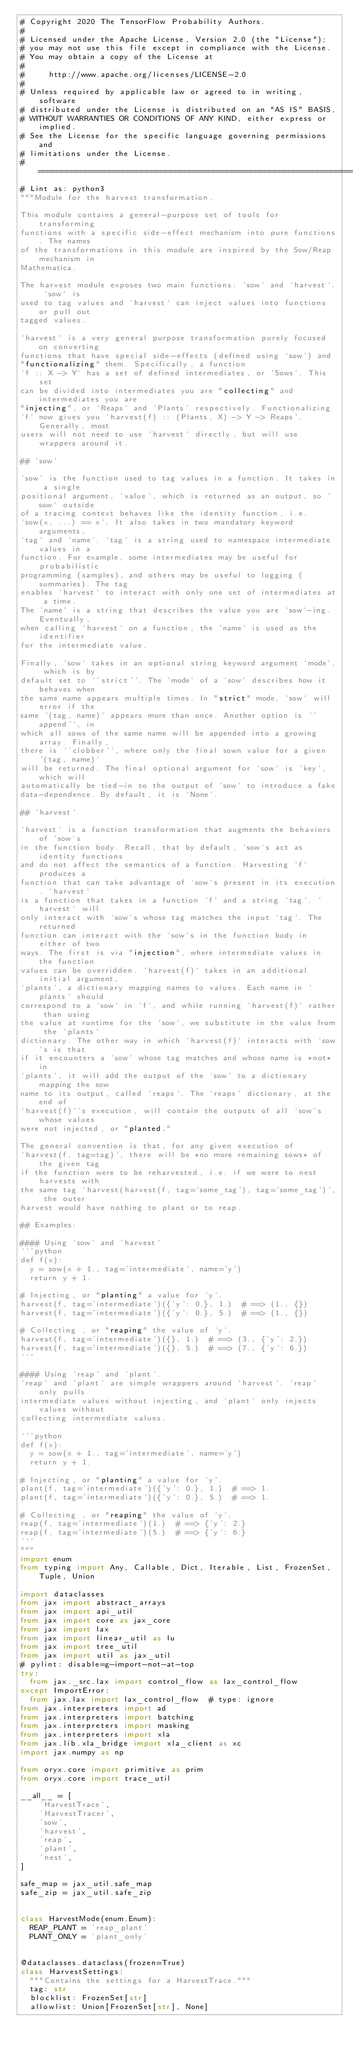<code> <loc_0><loc_0><loc_500><loc_500><_Python_># Copyright 2020 The TensorFlow Probability Authors.
#
# Licensed under the Apache License, Version 2.0 (the "License");
# you may not use this file except in compliance with the License.
# You may obtain a copy of the License at
#
#     http://www.apache.org/licenses/LICENSE-2.0
#
# Unless required by applicable law or agreed to in writing, software
# distributed under the License is distributed on an "AS IS" BASIS,
# WITHOUT WARRANTIES OR CONDITIONS OF ANY KIND, either express or implied.
# See the License for the specific language governing permissions and
# limitations under the License.
# ============================================================================
# Lint as: python3
"""Module for the harvest transformation.

This module contains a general-purpose set of tools for transforming
functions with a specific side-effect mechanism into pure functions. The names
of the transformations in this module are inspired by the Sow/Reap mechanism in
Mathematica.

The harvest module exposes two main functions: `sow` and `harvest`. `sow` is
used to tag values and `harvest` can inject values into functions or pull out
tagged values.

`harvest` is a very general purpose transformation purely focused on converting
functions that have special side-effects (defined using `sow`) and
"functionalizing" them. Specifically, a function
`f :: X -> Y` has a set of defined intermediates, or `Sows`. This set
can be divided into intermediates you are "collecting" and intermediates you are
"injecting", or `Reaps` and `Plants` respectively. Functionalizing
`f` now gives you `harvest(f) :: (Plants, X) -> Y -> Reaps`. Generally, most
users will not need to use `harvest` directly, but will use wrappers around it.

## `sow`

`sow` is the function used to tag values in a function. It takes in a single
positional argument, `value`, which is returned as an output, so `sow` outside
of a tracing context behaves like the identity function, i.e.
`sow(x, ...) == x`. It also takes in two mandatory keyword arguments,
`tag` and `name`. `tag` is a string used to namespace intermediate values in a
function. For example, some intermediates may be useful for probabilistic
programming (samples), and others may be useful to logging (summaries). The tag
enables `harvest` to interact with only one set of intermediates at a time.
The `name` is a string that describes the value you are `sow`-ing. Eventually,
when calling `harvest` on a function, the `name` is used as the identifier
for the intermediate value.

Finally, `sow` takes in an optional string keyword argument `mode`, which is by
default set to `'strict'`. The `mode` of a `sow` describes how it behaves when
the same name appears multiple times. In "strict" mode, `sow` will error if the
same `(tag, name)` appears more than once. Another option is `'append'`, in
which all sows of the same name will be appended into a growing array. Finally,
there is `'clobber'`, where only the final sown value for a given `(tag, name)`
will be returned. The final optional argument for `sow` is `key`, which will
automatically be tied-in to the output of `sow` to introduce a fake
data-dependence. By default, it is `None`.

## `harvest`

`harvest` is a function transformation that augments the behaviors of `sow`s
in the function body. Recall, that by default, `sow`s act as identity functions
and do not affect the semantics of a function. Harvesting `f` produces a
function that can take advantage of `sow`s present in its execution. `harvest`
is a function that takes in a function `f` and a string `tag`. `harvest` will
only interact with `sow`s whose tag matches the input `tag`. The returned
function can interact with the `sow`s in the function body in either of two
ways. The first is via "injection", where intermediate values in the function
values can be overridden. `harvest(f)` takes in an additional initial argument,
`plants`, a dictionary mapping names to values. Each name in `plants` should
correspond to a `sow` in `f`, and while running `harvest(f)` rather than using
the value at runtime for the `sow`, we substitute in the value from the `plants`
dictionary. The other way in which `harvest(f)` interacts with `sow`s is that
if it encounters a `sow` whose tag matches and whose name is *not* in
`plants`, it will add the output of the `sow` to a dictionary mapping the sow
name to its output, called `reaps`. The `reaps` dictionary, at the end of
`harvest(f)`'s execution, will contain the outputs of all `sow`s whose values
were not injected, or "planted."

The general convention is that, for any given execution of
`harvest(f, tag=tag)`, there will be *no more remaining sows* of the given tag
if the function were to be reharvested, i.e. if we were to nest harvests with
the same tag `harvest(harvest(f, tag='some_tag'), tag='some_tag')`, the outer
harvest would have nothing to plant or to reap.

## Examples:

#### Using `sow` and `harvest`
```python
def f(x):
  y = sow(x + 1., tag='intermediate', name='y')
  return y + 1.

# Injecting, or "planting" a value for `y`.
harvest(f, tag='intermediate')({'y': 0.}, 1.)  # ==> (1., {})
harvest(f, tag='intermediate')({'y': 0.}, 5.)  # ==> (1., {})

# Collecting , or "reaping" the value of `y`.
harvest(f, tag='intermediate')({}, 1.)  # ==> (3., {'y': 2.})
harvest(f, tag='intermediate')({}, 5.)  # ==> (7., {'y': 6.})
```

#### Using `reap` and `plant`.
`reap` and `plant` are simple wrappers around `harvest`. `reap` only pulls
intermediate values without injecting, and `plant` only injects values without
collecting intermediate values.

```python
def f(x):
  y = sow(x + 1., tag='intermediate', name='y')
  return y + 1.

# Injecting, or "planting" a value for `y`.
plant(f, tag='intermediate')({'y': 0.}, 1.)  # ==> 1.
plant(f, tag='intermediate')({'y': 0.}, 5.)  # ==> 1.

# Collecting , or "reaping" the value of `y`.
reap(f, tag='intermediate')(1.)  # ==> {'y': 2.}
reap(f, tag='intermediate')(5.)  # ==> {'y': 6.}
```
"""
import enum
from typing import Any, Callable, Dict, Iterable, List, FrozenSet, Tuple, Union

import dataclasses
from jax import abstract_arrays
from jax import api_util
from jax import core as jax_core
from jax import lax
from jax import linear_util as lu
from jax import tree_util
from jax import util as jax_util
# pylint: disable=g-import-not-at-top
try:
  from jax._src.lax import control_flow as lax_control_flow
except ImportError:
  from jax.lax import lax_control_flow  # type: ignore
from jax.interpreters import ad
from jax.interpreters import batching
from jax.interpreters import masking
from jax.interpreters import xla
from jax.lib.xla_bridge import xla_client as xc
import jax.numpy as np

from oryx.core import primitive as prim
from oryx.core import trace_util

__all__ = [
    'HarvestTrace',
    'HarvestTracer',
    'sow',
    'harvest',
    'reap',
    'plant',
    'nest',
]

safe_map = jax_util.safe_map
safe_zip = jax_util.safe_zip


class HarvestMode(enum.Enum):
  REAP_PLANT = 'reap_plant'
  PLANT_ONLY = 'plant_only'


@dataclasses.dataclass(frozen=True)
class HarvestSettings:
  """Contains the settings for a HarvestTrace."""
  tag: str
  blocklist: FrozenSet[str]
  allowlist: Union[FrozenSet[str], None]</code> 